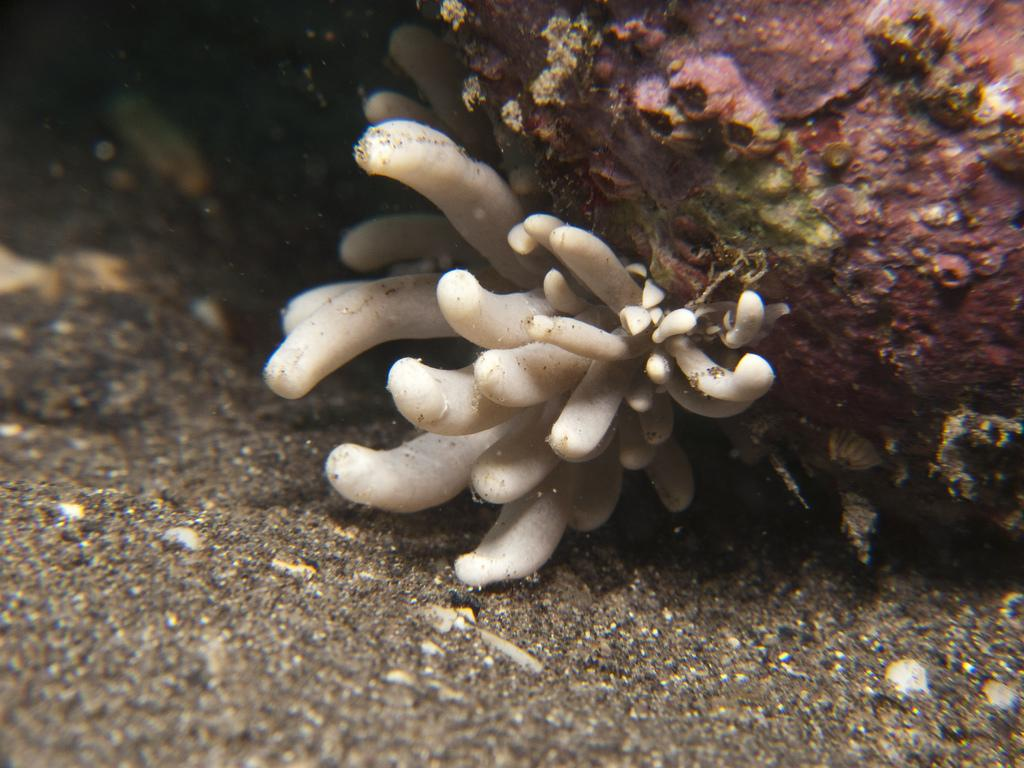What is the primary setting of the image? The image might have been clicked inside water. What can be seen at the bottom of the image? There is sand at the bottom of the image. What is located in the middle of the image? There is a plant in the middle of the image. What is visible at the top of the image? There is a rock visible at the top of the image. How many doors can be seen in the image? There are no doors present in the image. What type of hole is visible in the image? There is no hole visible in the image. 